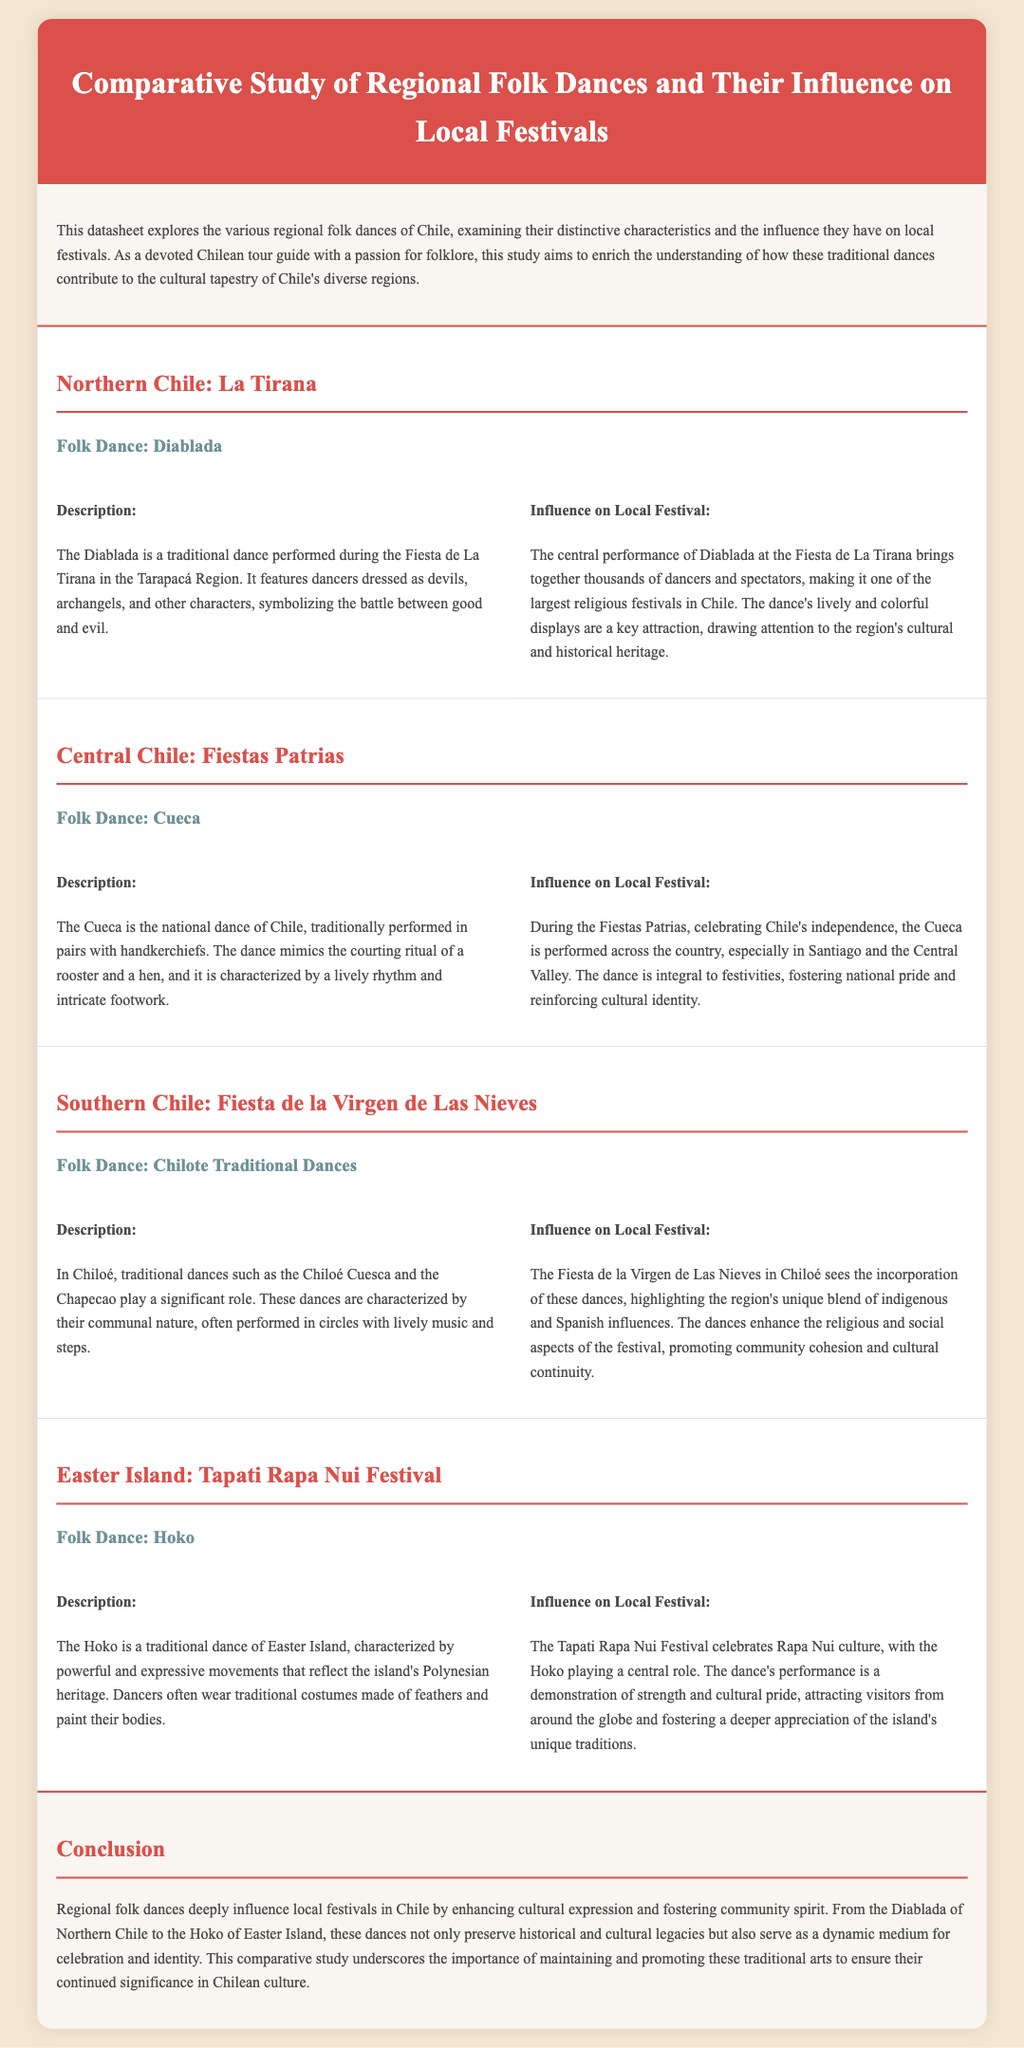What is the folk dance performed during Fiesta de La Tirana? The folk dance performed during the Fiesta de La Tirana is the Diablada.
Answer: Diablada What is the national dance of Chile? The national dance of Chile is the Cueca.
Answer: Cueca Which festival incorporates Chilote traditional dances? The Fiesta de la Virgen de Las Nieves incorporates Chilote traditional dances.
Answer: Fiesta de la Virgen de Las Nieves What characterizes the Hoko dance? The Hoko dance is characterized by powerful and expressive movements.
Answer: Powerful and expressive movements How does the Diablada influence the Fiesta de La Tirana? The Diablada's performance brings together thousands of dancers and spectators, making it a key attraction of the festival.
Answer: Key attraction What do the Cueca dancers mimic? The Cueca dancers mimic the courting ritual of a rooster and a hen.
Answer: Courting ritual What is a significant aspect of the Chilote traditional dances? A significant aspect of the Chilote traditional dances is their communal nature.
Answer: Communal nature How is the Hoko related to Rapa Nui culture? The Hoko is a demonstration of strength and cultural pride, central to the Tapati Rapa Nui Festival.
Answer: Central to the Tapati Rapa Nui Festival What does the conclusion emphasize about regional folk dances in Chile? The conclusion emphasizes maintaining and promoting these traditional arts to ensure their continued significance.
Answer: Continued significance 